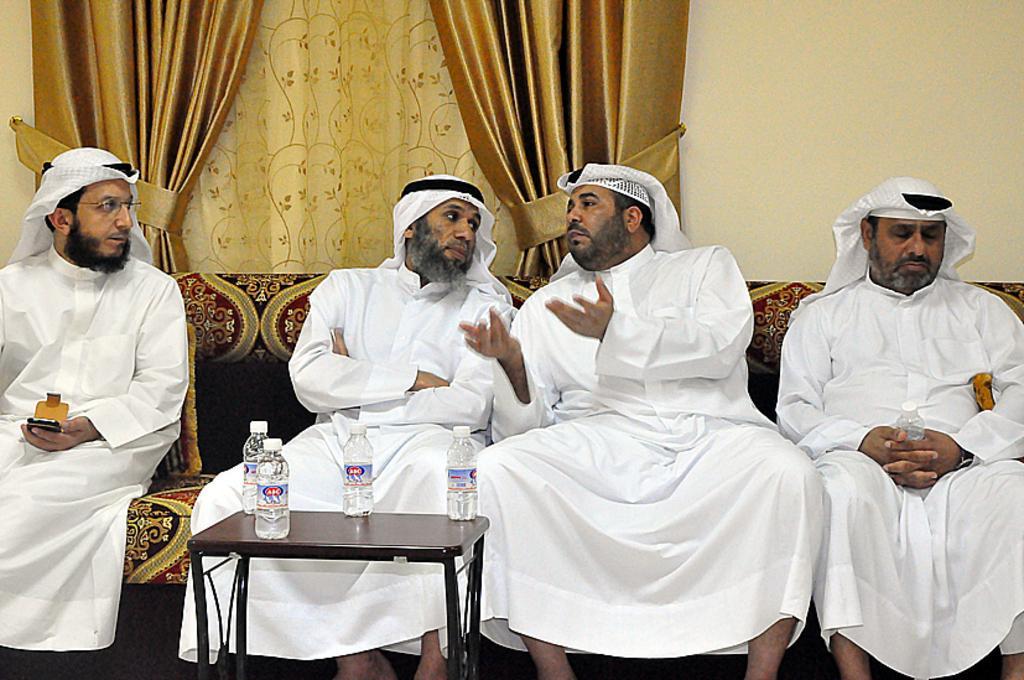Can you describe this image briefly? We can see curtains , wall on the background. We can see four men sitting on the sofa in front of a table and on the table we can see four water bottles. This man is holding a mobile in his hand and he is holding a water bottle. These both men are talking. 